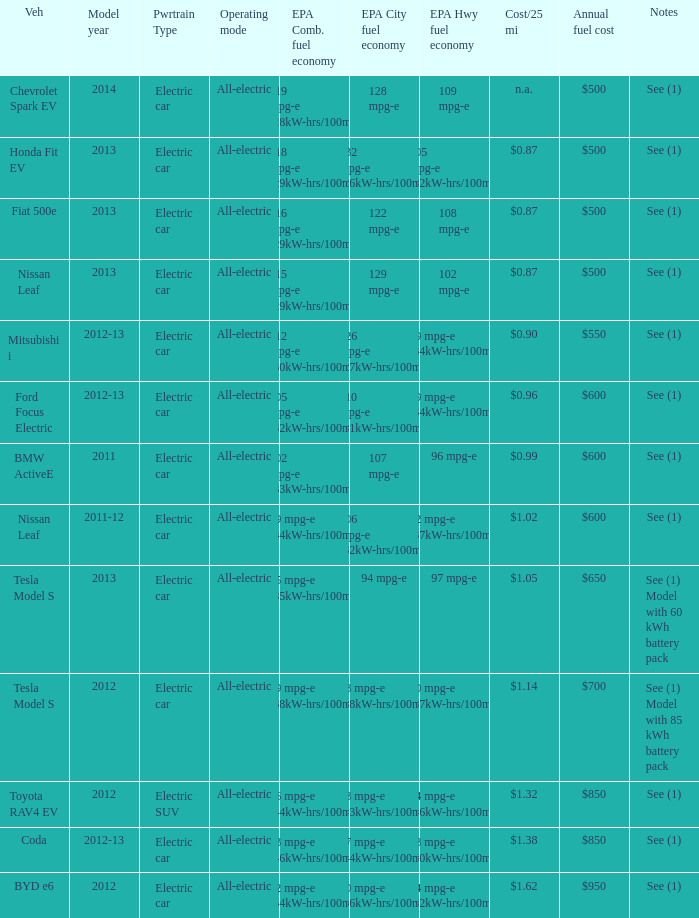What is the epa highway fuel economy for an electric suv? 74 mpg-e (46kW-hrs/100mi). 